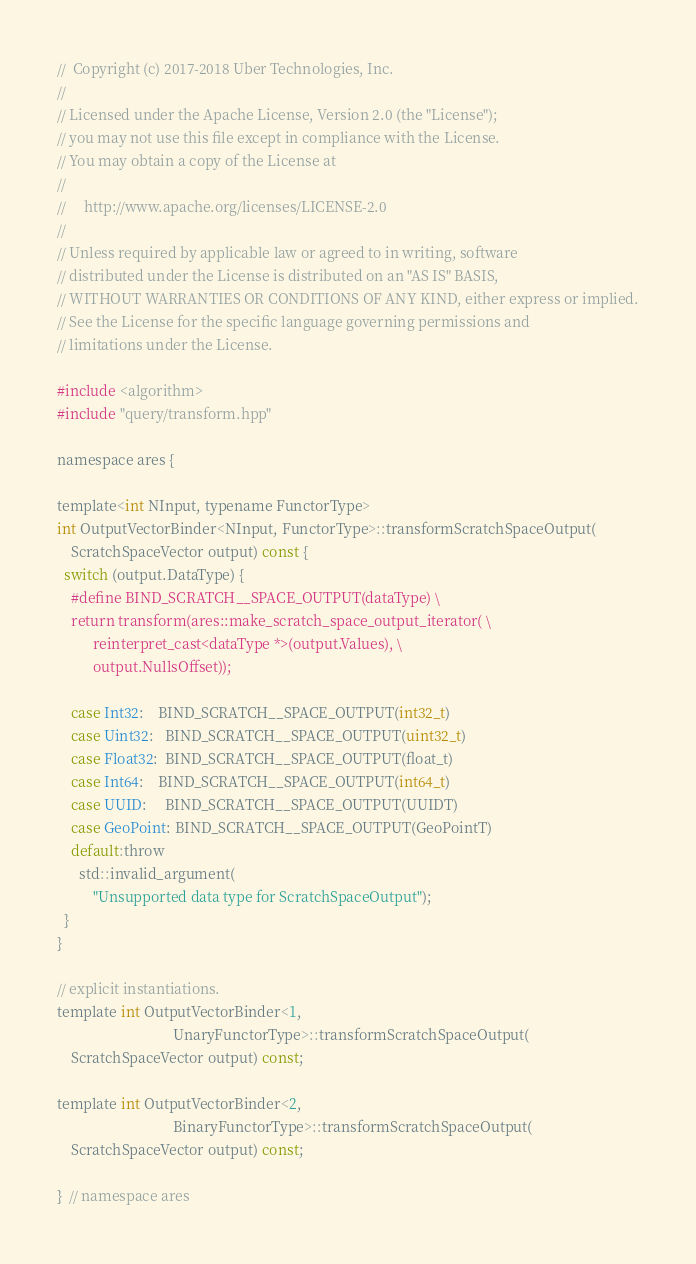Convert code to text. <code><loc_0><loc_0><loc_500><loc_500><_Cuda_>//  Copyright (c) 2017-2018 Uber Technologies, Inc.
//
// Licensed under the Apache License, Version 2.0 (the "License");
// you may not use this file except in compliance with the License.
// You may obtain a copy of the License at
//
//     http://www.apache.org/licenses/LICENSE-2.0
//
// Unless required by applicable law or agreed to in writing, software
// distributed under the License is distributed on an "AS IS" BASIS,
// WITHOUT WARRANTIES OR CONDITIONS OF ANY KIND, either express or implied.
// See the License for the specific language governing permissions and
// limitations under the License.

#include <algorithm>
#include "query/transform.hpp"

namespace ares {

template<int NInput, typename FunctorType>
int OutputVectorBinder<NInput, FunctorType>::transformScratchSpaceOutput(
    ScratchSpaceVector output) const {
  switch (output.DataType) {
    #define BIND_SCRATCH__SPACE_OUTPUT(dataType) \
    return transform(ares::make_scratch_space_output_iterator( \
          reinterpret_cast<dataType *>(output.Values), \
          output.NullsOffset));

    case Int32:    BIND_SCRATCH__SPACE_OUTPUT(int32_t)
    case Uint32:   BIND_SCRATCH__SPACE_OUTPUT(uint32_t)
    case Float32:  BIND_SCRATCH__SPACE_OUTPUT(float_t)
    case Int64:    BIND_SCRATCH__SPACE_OUTPUT(int64_t)
    case UUID:     BIND_SCRATCH__SPACE_OUTPUT(UUIDT)
    case GeoPoint: BIND_SCRATCH__SPACE_OUTPUT(GeoPointT)
    default:throw
      std::invalid_argument(
          "Unsupported data type for ScratchSpaceOutput");
  }
}

// explicit instantiations.
template int OutputVectorBinder<1,
                                UnaryFunctorType>::transformScratchSpaceOutput(
    ScratchSpaceVector output) const;

template int OutputVectorBinder<2,
                                BinaryFunctorType>::transformScratchSpaceOutput(
    ScratchSpaceVector output) const;

}  // namespace ares
</code> 